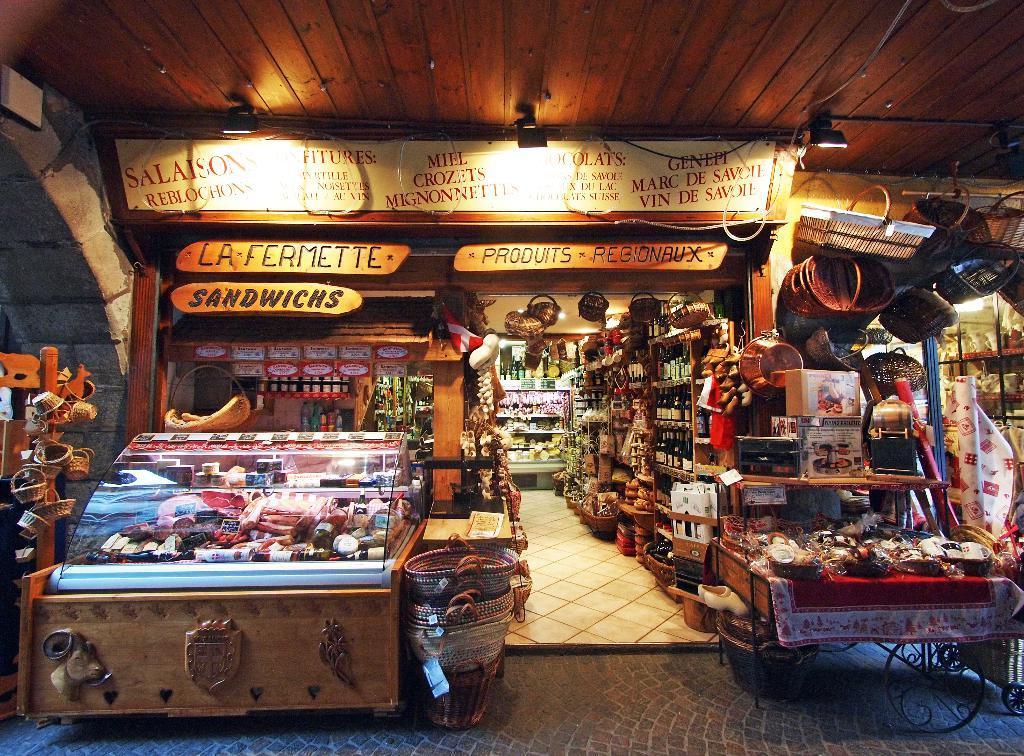<image>
Describe the image concisely. A store has signs that read la fermette, sandwichs, and produits regionbux. 